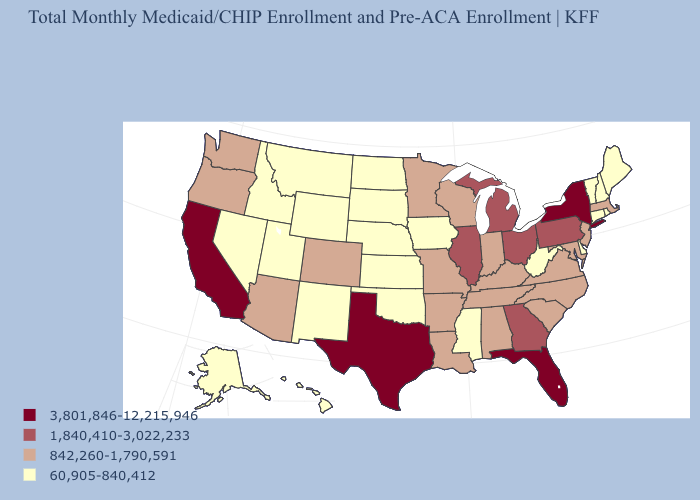Which states have the highest value in the USA?
Quick response, please. California, Florida, New York, Texas. Among the states that border Texas , does Arkansas have the lowest value?
Concise answer only. No. Among the states that border Louisiana , which have the lowest value?
Concise answer only. Mississippi. Among the states that border Oregon , does Idaho have the lowest value?
Answer briefly. Yes. Is the legend a continuous bar?
Concise answer only. No. What is the lowest value in the MidWest?
Answer briefly. 60,905-840,412. Does the map have missing data?
Be succinct. No. What is the highest value in the West ?
Give a very brief answer. 3,801,846-12,215,946. What is the value of Connecticut?
Be succinct. 60,905-840,412. Does New York have the lowest value in the USA?
Keep it brief. No. Which states hav the highest value in the MidWest?
Answer briefly. Illinois, Michigan, Ohio. Does Idaho have the highest value in the USA?
Short answer required. No. What is the value of Connecticut?
Give a very brief answer. 60,905-840,412. What is the value of Colorado?
Give a very brief answer. 842,260-1,790,591. 